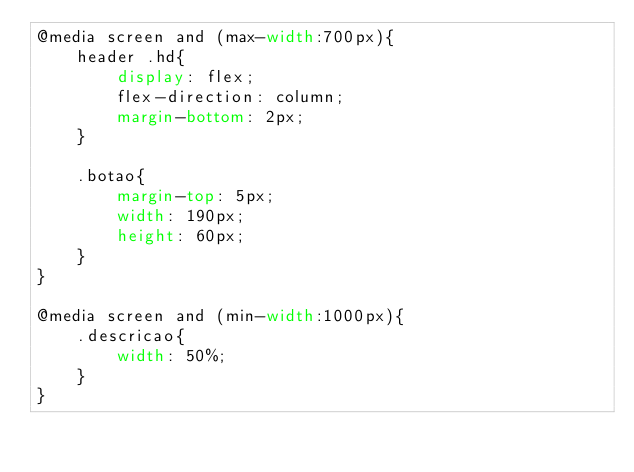<code> <loc_0><loc_0><loc_500><loc_500><_CSS_>@media screen and (max-width:700px){
    header .hd{
        display: flex;
        flex-direction: column;
        margin-bottom: 2px;
    }

    .botao{
        margin-top: 5px;
        width: 190px;
        height: 60px;
    }
}

@media screen and (min-width:1000px){
    .descricao{
        width: 50%;
    }
}
</code> 